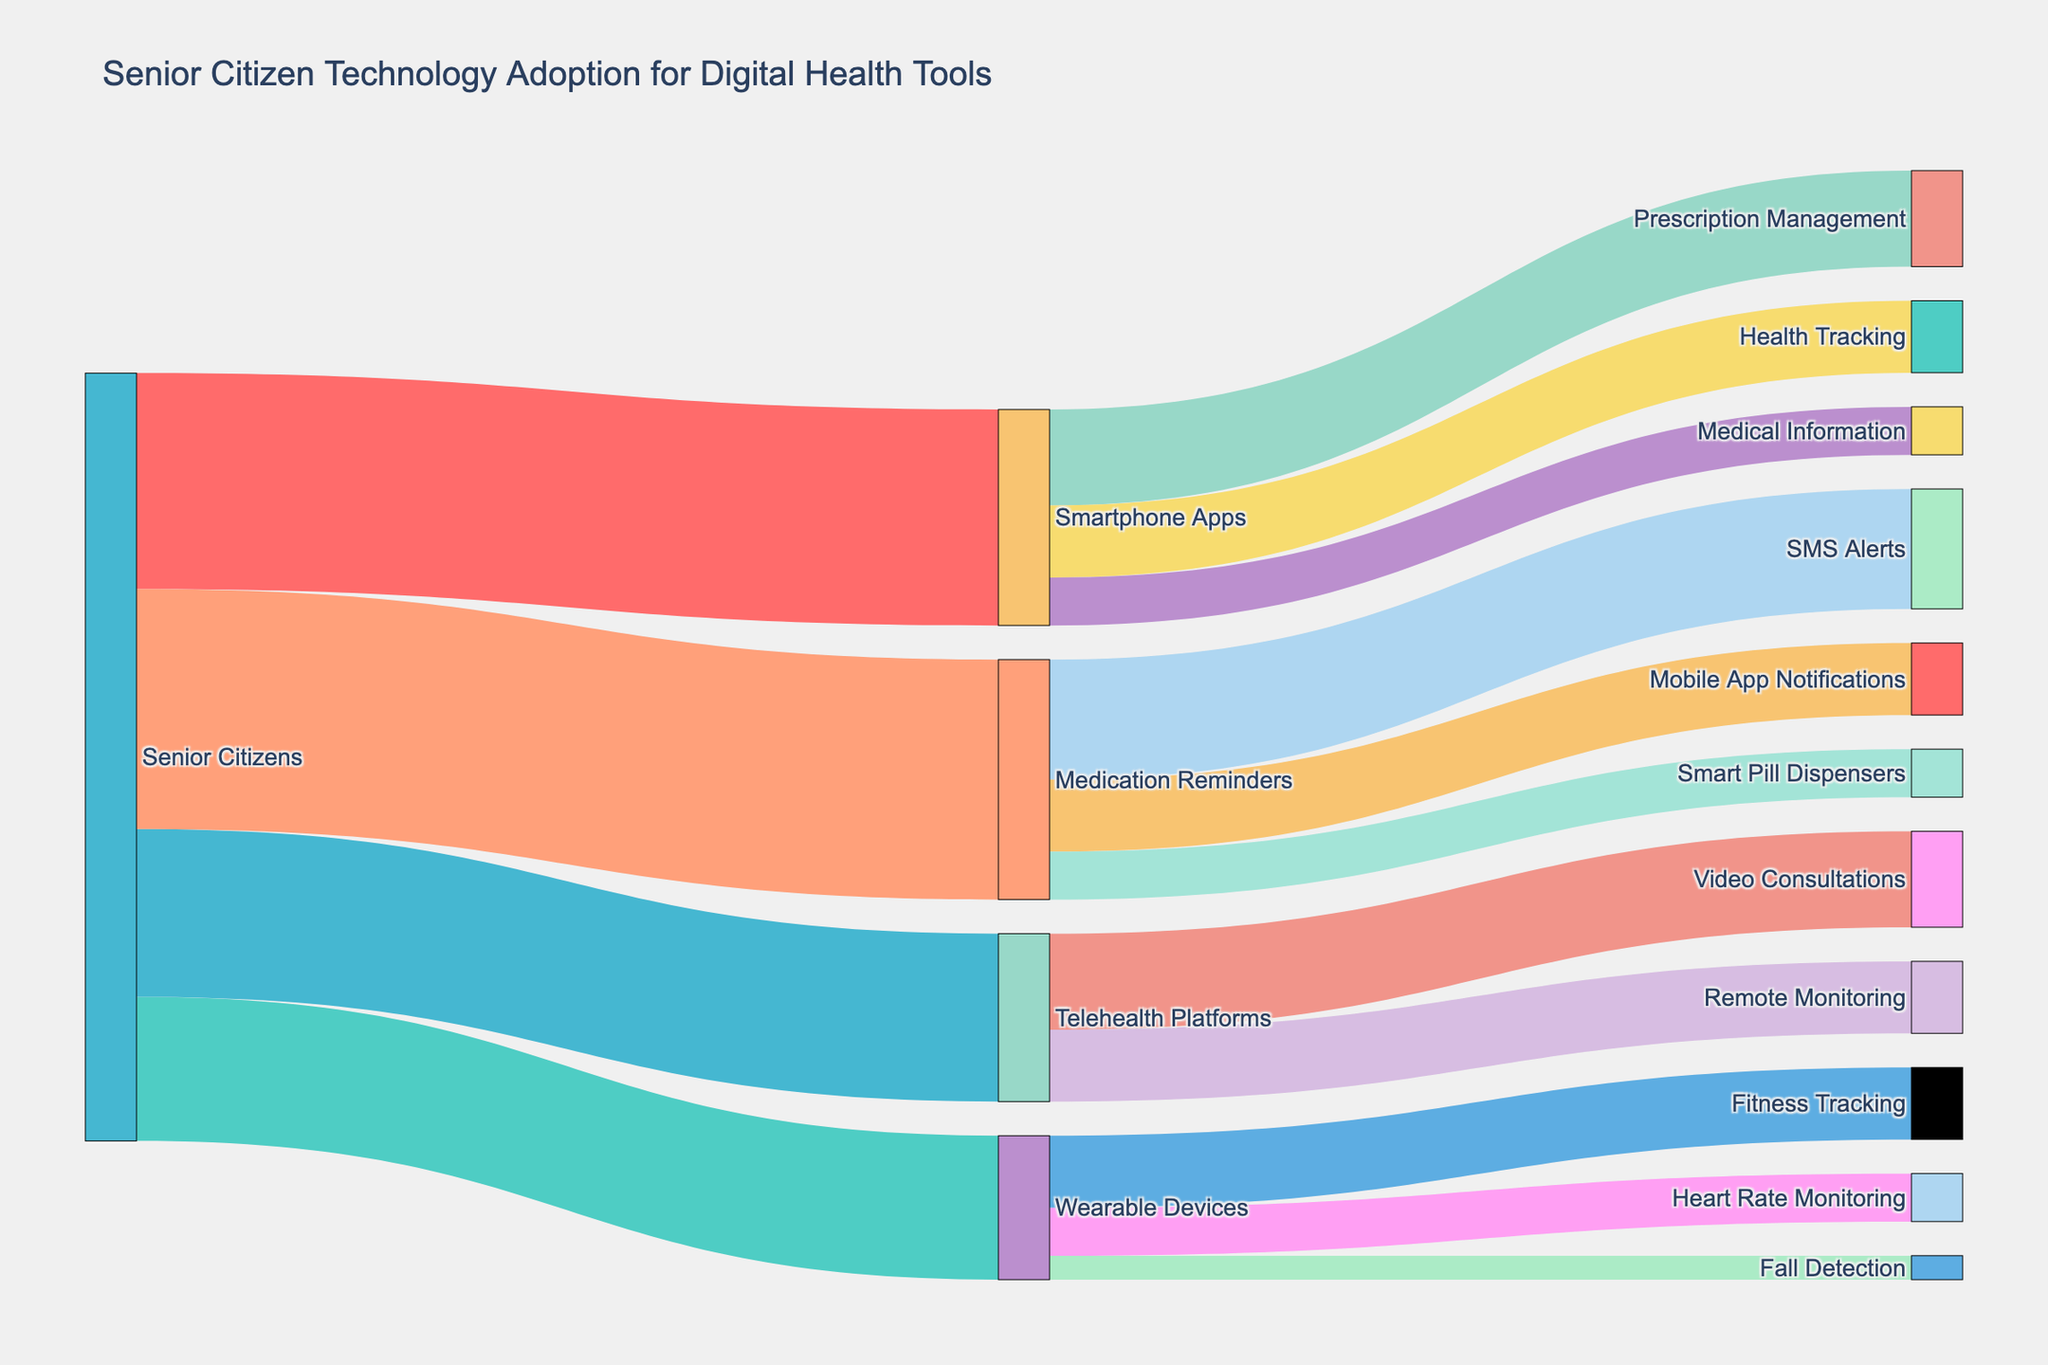Which digital health tool has the most adoption among senior citizens? To find the tool with the most adoption, look for the largest value flowing out from the "Senior Citizens" node. The highest value is 50, which corresponds to "Medication Reminders".
Answer: Medication Reminders How many senior citizens use Telehealth Platforms? Look for the value linking "Senior Citizens" to "Telehealth Platforms". The value is 35.
Answer: 35 What is the combined adoption rate of Wearable Devices and Smartphone Apps among senior citizens? Sum the values of "Wearable Devices" and "Smartphone Apps". "Wearable Devices" has a value of 30, and "Smartphone Apps" has a value of 45. Addition: 30 + 45 = 75.
Answer: 75 Which feature of Smartphone Apps is the least adopted among senior citizens? Check the values flowing out from "Smartphone Apps" and find the smallest one. The values are 20 (Prescription Management), 15 (Health Tracking), and 10 (Medical Information). The smallest is 10, which corresponds to "Medical Information".
Answer: Medical Information How many senior citizens use SMS Alerts for Medication Reminders? Look for the value linking "Medication Reminders" to "SMS Alerts". The value is 25.
Answer: 25 Compare the adoption rates of Fitness Tracking and Heart Rate Monitoring among those who use Wearable Devices. Check the values flowing out from "Wearable Devices". The values are 15 for "Fitness Tracking" and 10 for "Heart Rate Monitoring". Fitness Tracking > Heart Rate Monitoring.
Answer: Fitness Tracking What percentage of senior citizens using Smartphone Apps use it for Health Tracking? First, find the number of senior citizens using Smartphone Apps, which is 45. Then, find the number who use it for Health Tracking, which is 15. Calculate the percentage: (15/45) * 100 ≈ 33.33%.
Answer: Approximately 33.33% What is the total number of senior citizens adopting Prescription Management, added across all digital tools? Only Smartphone Apps lead to Prescription Management. The value is 20 from Smartphone Apps.
Answer: 20 Which feature has the highest adoption rate among senior citizens using Telehealth Platforms? Check the values flowing out from "Telehealth Platforms". The values are 20 for "Video Consultations" and 15 for "Remote Monitoring". "Video Consultations" has the highest rate.
Answer: Video Consultations What is the combined value of senior citizens using Mobile App Notifications and Smart Pill Dispensers for Medication Reminders? Sum the values "Mobile App Notifications" and "Smart Pill Dispensers" under "Medication Reminders". The values are 15 and 10, respectively. Addition: 15 + 10 = 25.
Answer: 25 